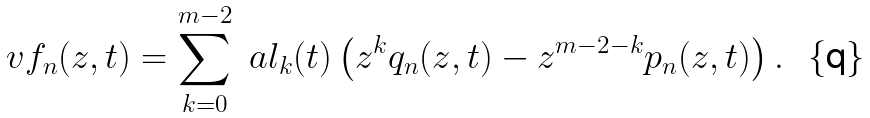<formula> <loc_0><loc_0><loc_500><loc_500>\ v f _ { n } ( z , t ) = \sum _ { k = 0 } ^ { m - 2 } \ a l _ { k } ( t ) \left ( z ^ { k } q _ { n } ( z , t ) - z ^ { m - 2 - k } p _ { n } ( z , t ) \right ) .</formula> 